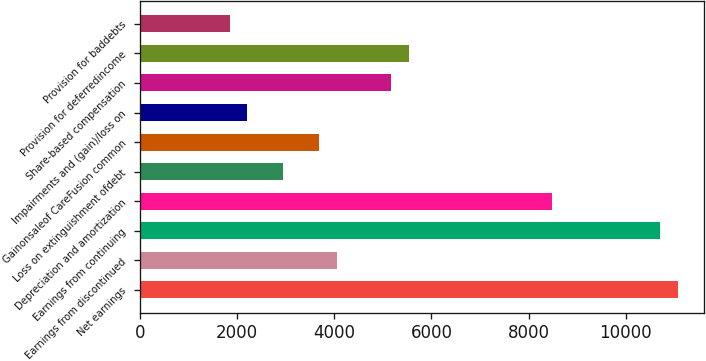Convert chart to OTSL. <chart><loc_0><loc_0><loc_500><loc_500><bar_chart><fcel>Net earnings<fcel>Earnings from discontinued<fcel>Earnings from continuing<fcel>Depreciation and amortization<fcel>Loss on extinguishment ofdebt<fcel>Gainonsaleof CareFusion common<fcel>Impairments and (gain)/loss on<fcel>Share-based compensation<fcel>Provision for deferredincome<fcel>Provision for baddebts<nl><fcel>11063.2<fcel>4058.09<fcel>10694.5<fcel>8482.37<fcel>2952.02<fcel>3689.4<fcel>2214.64<fcel>5164.16<fcel>5532.85<fcel>1845.95<nl></chart> 